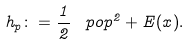Convert formula to latex. <formula><loc_0><loc_0><loc_500><loc_500>h _ { p } \colon = \frac { 1 } { 2 } \, \ p o p ^ { 2 } + E ( x ) .</formula> 